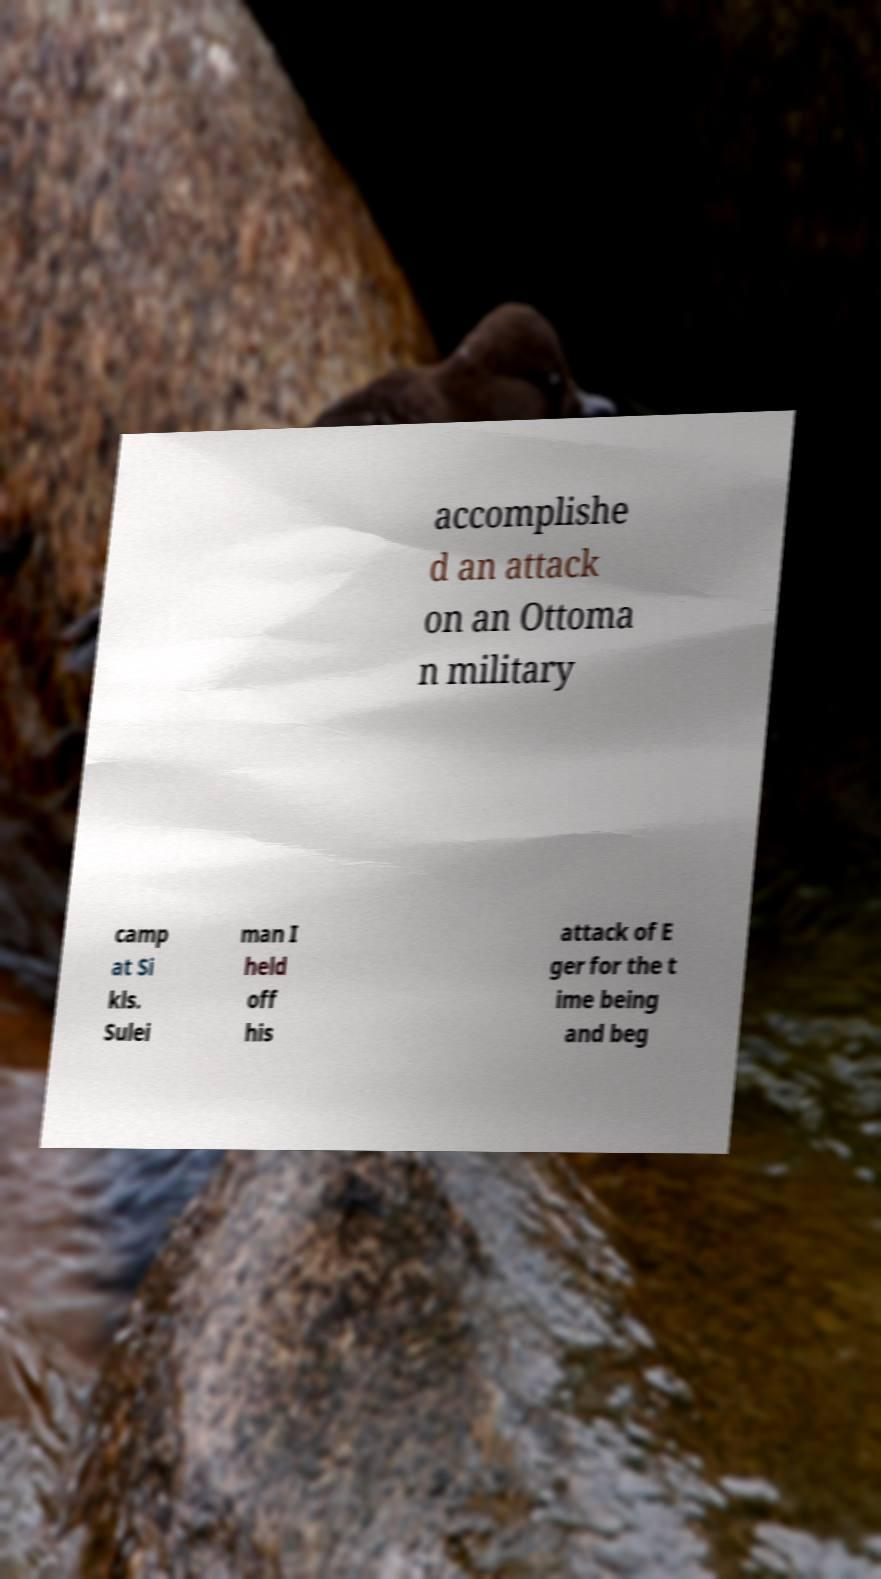What messages or text are displayed in this image? I need them in a readable, typed format. accomplishe d an attack on an Ottoma n military camp at Si kls. Sulei man I held off his attack of E ger for the t ime being and beg 